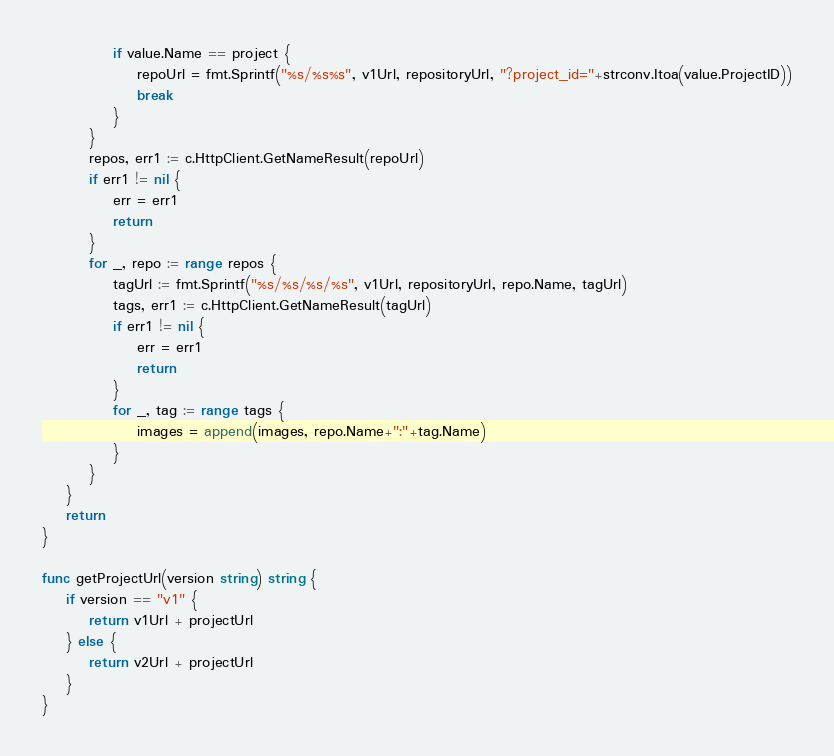Convert code to text. <code><loc_0><loc_0><loc_500><loc_500><_Go_>			if value.Name == project {
				repoUrl = fmt.Sprintf("%s/%s%s", v1Url, repositoryUrl, "?project_id="+strconv.Itoa(value.ProjectID))
				break
			}
		}
		repos, err1 := c.HttpClient.GetNameResult(repoUrl)
		if err1 != nil {
			err = err1
			return
		}
		for _, repo := range repos {
			tagUrl := fmt.Sprintf("%s/%s/%s/%s", v1Url, repositoryUrl, repo.Name, tagUrl)
			tags, err1 := c.HttpClient.GetNameResult(tagUrl)
			if err1 != nil {
				err = err1
				return
			}
			for _, tag := range tags {
				images = append(images, repo.Name+":"+tag.Name)
			}
		}
	}
	return
}

func getProjectUrl(version string) string {
	if version == "v1" {
		return v1Url + projectUrl
	} else {
		return v2Url + projectUrl
	}
}
</code> 